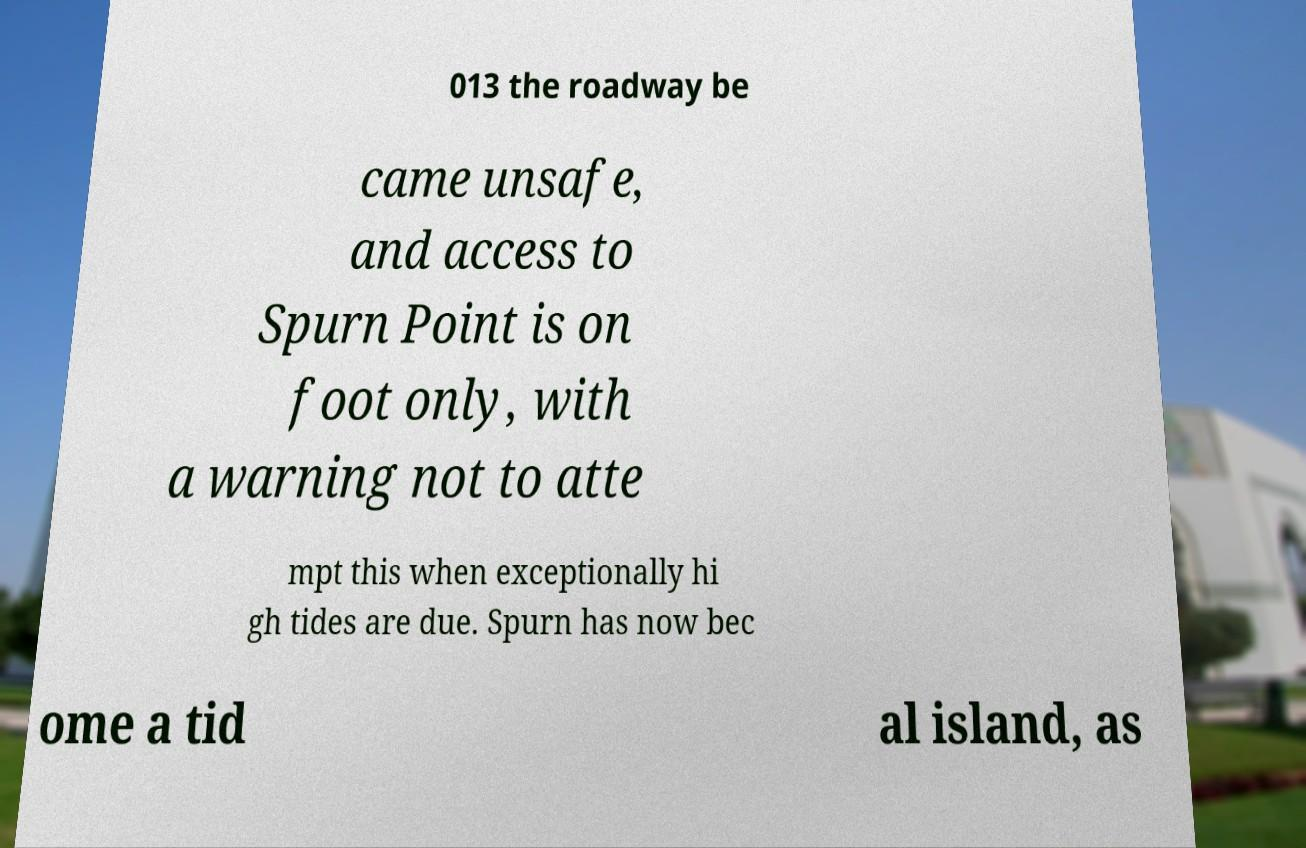What messages or text are displayed in this image? I need them in a readable, typed format. 013 the roadway be came unsafe, and access to Spurn Point is on foot only, with a warning not to atte mpt this when exceptionally hi gh tides are due. Spurn has now bec ome a tid al island, as 